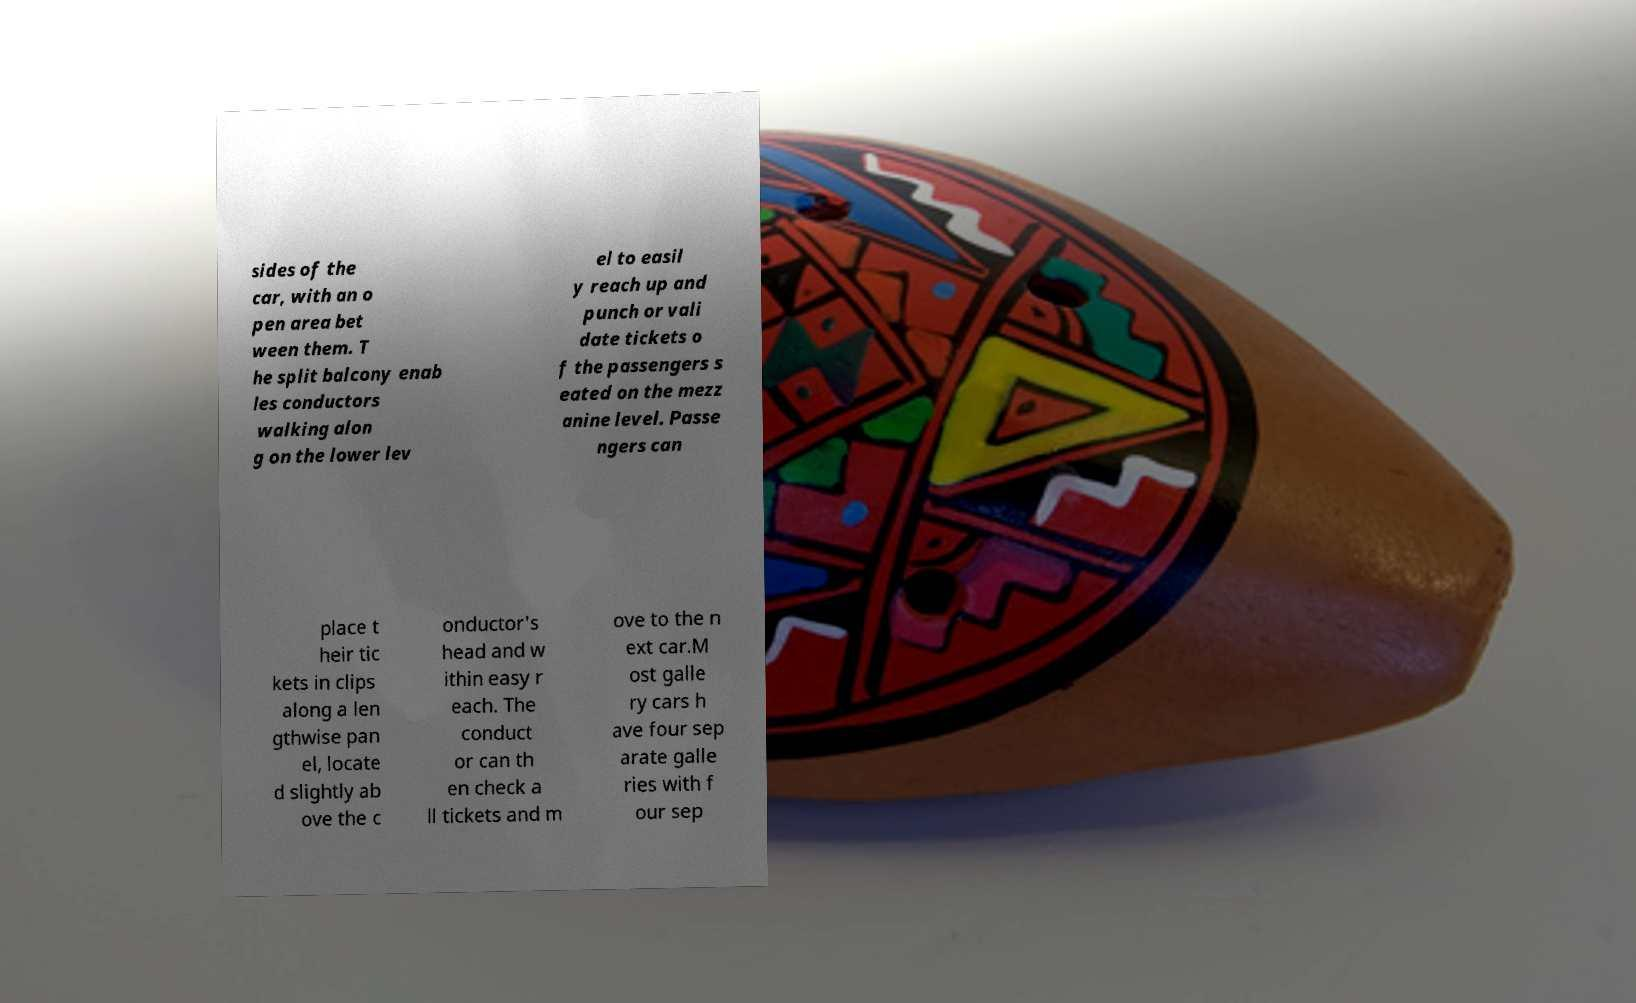Can you read and provide the text displayed in the image?This photo seems to have some interesting text. Can you extract and type it out for me? sides of the car, with an o pen area bet ween them. T he split balcony enab les conductors walking alon g on the lower lev el to easil y reach up and punch or vali date tickets o f the passengers s eated on the mezz anine level. Passe ngers can place t heir tic kets in clips along a len gthwise pan el, locate d slightly ab ove the c onductor's head and w ithin easy r each. The conduct or can th en check a ll tickets and m ove to the n ext car.M ost galle ry cars h ave four sep arate galle ries with f our sep 